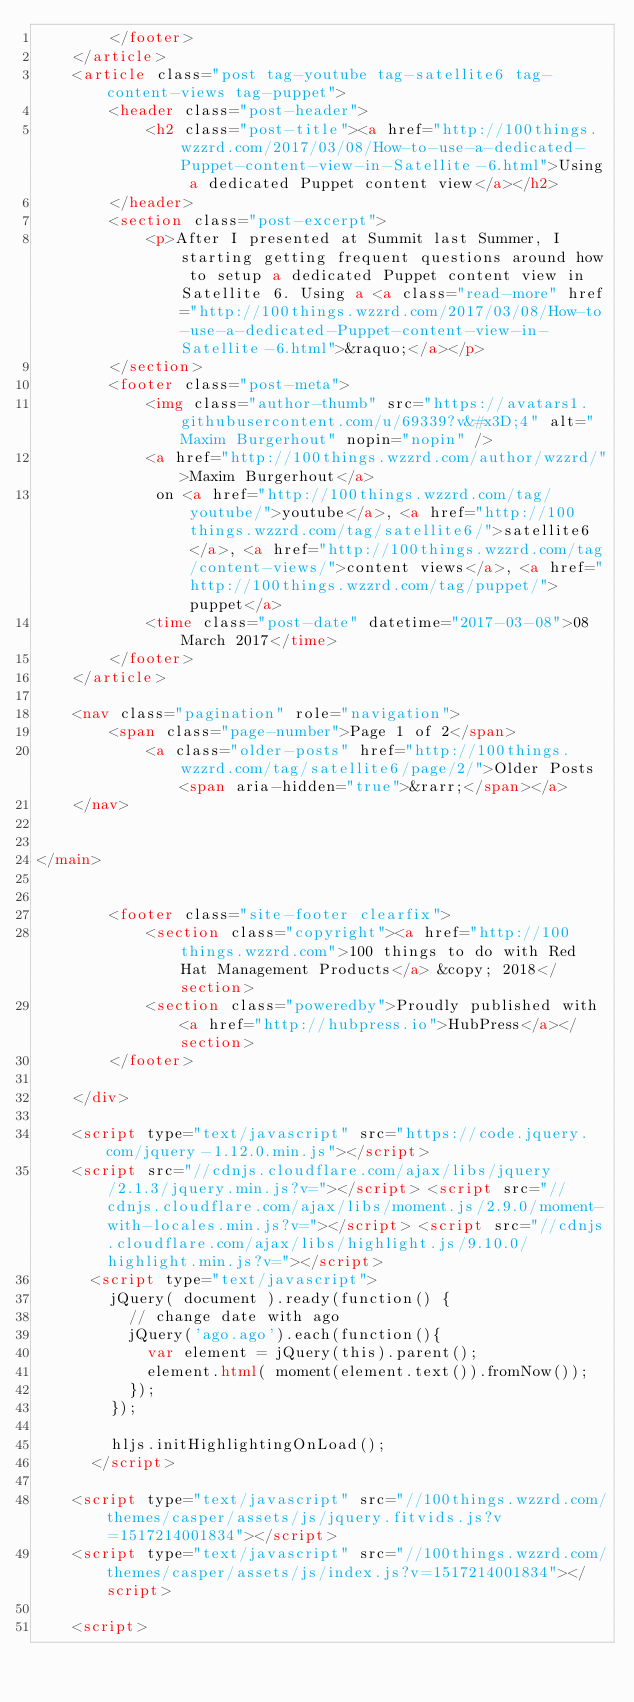Convert code to text. <code><loc_0><loc_0><loc_500><loc_500><_HTML_>        </footer>
    </article>
    <article class="post tag-youtube tag-satellite6 tag-content-views tag-puppet">
        <header class="post-header">
            <h2 class="post-title"><a href="http://100things.wzzrd.com/2017/03/08/How-to-use-a-dedicated-Puppet-content-view-in-Satellite-6.html">Using a dedicated Puppet content view</a></h2>
        </header>
        <section class="post-excerpt">
            <p>After I presented at Summit last Summer, I starting getting frequent questions around how to setup a dedicated Puppet content view in Satellite 6. Using a <a class="read-more" href="http://100things.wzzrd.com/2017/03/08/How-to-use-a-dedicated-Puppet-content-view-in-Satellite-6.html">&raquo;</a></p>
        </section>
        <footer class="post-meta">
            <img class="author-thumb" src="https://avatars1.githubusercontent.com/u/69339?v&#x3D;4" alt="Maxim Burgerhout" nopin="nopin" />
            <a href="http://100things.wzzrd.com/author/wzzrd/">Maxim Burgerhout</a>
             on <a href="http://100things.wzzrd.com/tag/youtube/">youtube</a>, <a href="http://100things.wzzrd.com/tag/satellite6/">satellite6</a>, <a href="http://100things.wzzrd.com/tag/content-views/">content views</a>, <a href="http://100things.wzzrd.com/tag/puppet/">puppet</a>
            <time class="post-date" datetime="2017-03-08">08 March 2017</time>
        </footer>
    </article>
    
    <nav class="pagination" role="navigation">
        <span class="page-number">Page 1 of 2</span>
            <a class="older-posts" href="http://100things.wzzrd.com/tag/satellite6/page/2/">Older Posts <span aria-hidden="true">&rarr;</span></a>
    </nav>
    

</main>


        <footer class="site-footer clearfix">
            <section class="copyright"><a href="http://100things.wzzrd.com">100 things to do with Red Hat Management Products</a> &copy; 2018</section>
            <section class="poweredby">Proudly published with <a href="http://hubpress.io">HubPress</a></section>
        </footer>

    </div>

    <script type="text/javascript" src="https://code.jquery.com/jquery-1.12.0.min.js"></script>
    <script src="//cdnjs.cloudflare.com/ajax/libs/jquery/2.1.3/jquery.min.js?v="></script> <script src="//cdnjs.cloudflare.com/ajax/libs/moment.js/2.9.0/moment-with-locales.min.js?v="></script> <script src="//cdnjs.cloudflare.com/ajax/libs/highlight.js/9.10.0/highlight.min.js?v="></script> 
      <script type="text/javascript">
        jQuery( document ).ready(function() {
          // change date with ago
          jQuery('ago.ago').each(function(){
            var element = jQuery(this).parent();
            element.html( moment(element.text()).fromNow());
          });
        });

        hljs.initHighlightingOnLoad();
      </script>

    <script type="text/javascript" src="//100things.wzzrd.com/themes/casper/assets/js/jquery.fitvids.js?v=1517214001834"></script>
    <script type="text/javascript" src="//100things.wzzrd.com/themes/casper/assets/js/index.js?v=1517214001834"></script>

    <script></code> 